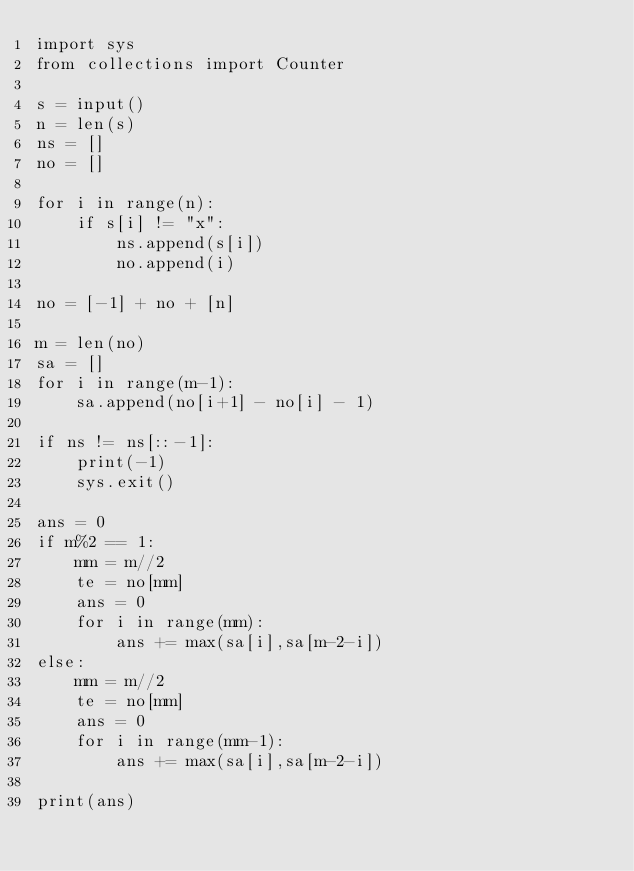<code> <loc_0><loc_0><loc_500><loc_500><_Python_>import sys
from collections import Counter

s = input()
n = len(s)
ns = []
no = []

for i in range(n):
    if s[i] != "x":
        ns.append(s[i])
        no.append(i)
        
no = [-1] + no + [n]
        
m = len(no) 
sa = []
for i in range(m-1):
    sa.append(no[i+1] - no[i] - 1)
        
if ns != ns[::-1]:
    print(-1)
    sys.exit()
    
ans = 0
if m%2 == 1:
    mm = m//2
    te = no[mm]
    ans = 0
    for i in range(mm):
        ans += max(sa[i],sa[m-2-i])
else:
    mm = m//2
    te = no[mm]
    ans = 0
    for i in range(mm-1):
        ans += max(sa[i],sa[m-2-i])
        
print(ans)</code> 